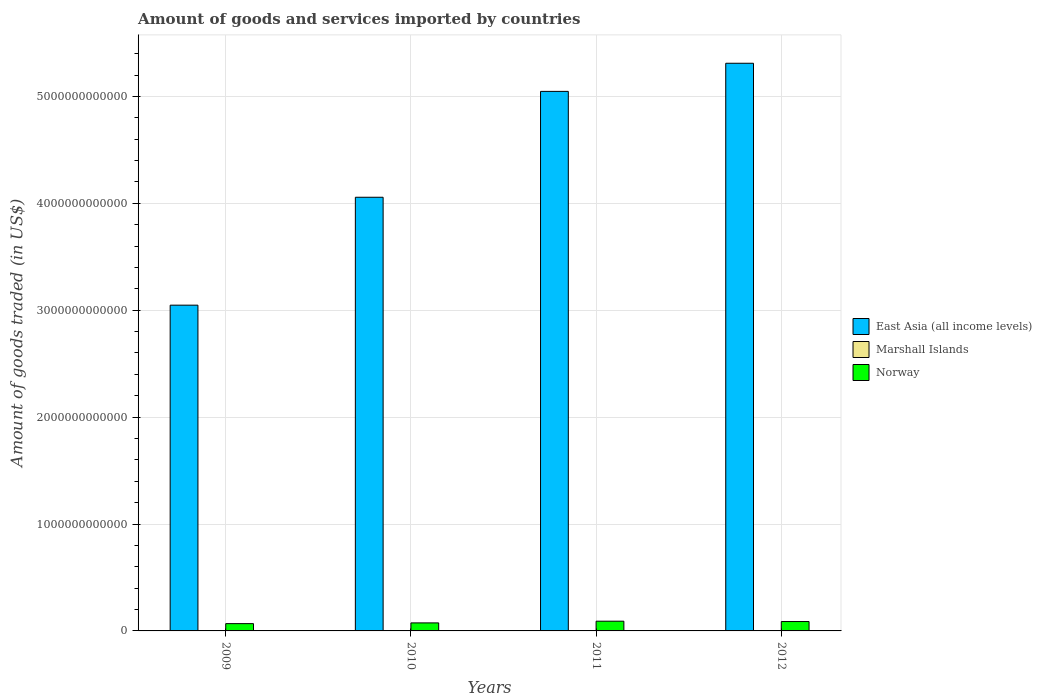Are the number of bars on each tick of the X-axis equal?
Keep it short and to the point. Yes. How many bars are there on the 2nd tick from the left?
Make the answer very short. 3. How many bars are there on the 2nd tick from the right?
Ensure brevity in your answer.  3. What is the label of the 1st group of bars from the left?
Provide a short and direct response. 2009. What is the total amount of goods and services imported in East Asia (all income levels) in 2009?
Ensure brevity in your answer.  3.05e+12. Across all years, what is the maximum total amount of goods and services imported in Marshall Islands?
Provide a short and direct response. 1.22e+08. Across all years, what is the minimum total amount of goods and services imported in Norway?
Make the answer very short. 6.81e+1. In which year was the total amount of goods and services imported in Marshall Islands maximum?
Offer a terse response. 2012. What is the total total amount of goods and services imported in East Asia (all income levels) in the graph?
Provide a short and direct response. 1.75e+13. What is the difference between the total amount of goods and services imported in East Asia (all income levels) in 2011 and that in 2012?
Offer a very short reply. -2.63e+11. What is the difference between the total amount of goods and services imported in Marshall Islands in 2009 and the total amount of goods and services imported in East Asia (all income levels) in 2012?
Provide a succinct answer. -5.31e+12. What is the average total amount of goods and services imported in Norway per year?
Offer a terse response. 8.05e+1. In the year 2010, what is the difference between the total amount of goods and services imported in Marshall Islands and total amount of goods and services imported in East Asia (all income levels)?
Your answer should be very brief. -4.06e+12. In how many years, is the total amount of goods and services imported in Marshall Islands greater than 3800000000000 US$?
Your answer should be very brief. 0. What is the ratio of the total amount of goods and services imported in East Asia (all income levels) in 2009 to that in 2011?
Offer a very short reply. 0.6. What is the difference between the highest and the second highest total amount of goods and services imported in Norway?
Keep it short and to the point. 3.21e+09. What is the difference between the highest and the lowest total amount of goods and services imported in East Asia (all income levels)?
Your response must be concise. 2.26e+12. What does the 2nd bar from the left in 2010 represents?
Provide a succinct answer. Marshall Islands. Is it the case that in every year, the sum of the total amount of goods and services imported in Norway and total amount of goods and services imported in Marshall Islands is greater than the total amount of goods and services imported in East Asia (all income levels)?
Provide a short and direct response. No. How many bars are there?
Keep it short and to the point. 12. How many years are there in the graph?
Ensure brevity in your answer.  4. What is the difference between two consecutive major ticks on the Y-axis?
Make the answer very short. 1.00e+12. Are the values on the major ticks of Y-axis written in scientific E-notation?
Provide a succinct answer. No. Does the graph contain any zero values?
Provide a short and direct response. No. What is the title of the graph?
Keep it short and to the point. Amount of goods and services imported by countries. Does "Palau" appear as one of the legend labels in the graph?
Your answer should be compact. No. What is the label or title of the Y-axis?
Make the answer very short. Amount of goods traded (in US$). What is the Amount of goods traded (in US$) in East Asia (all income levels) in 2009?
Ensure brevity in your answer.  3.05e+12. What is the Amount of goods traded (in US$) of Marshall Islands in 2009?
Keep it short and to the point. 9.43e+07. What is the Amount of goods traded (in US$) in Norway in 2009?
Provide a succinct answer. 6.81e+1. What is the Amount of goods traded (in US$) of East Asia (all income levels) in 2010?
Keep it short and to the point. 4.06e+12. What is the Amount of goods traded (in US$) in Marshall Islands in 2010?
Keep it short and to the point. 1.10e+08. What is the Amount of goods traded (in US$) of Norway in 2010?
Make the answer very short. 7.50e+1. What is the Amount of goods traded (in US$) in East Asia (all income levels) in 2011?
Ensure brevity in your answer.  5.05e+12. What is the Amount of goods traded (in US$) in Marshall Islands in 2011?
Your response must be concise. 1.17e+08. What is the Amount of goods traded (in US$) of Norway in 2011?
Your answer should be compact. 9.10e+1. What is the Amount of goods traded (in US$) of East Asia (all income levels) in 2012?
Your answer should be very brief. 5.31e+12. What is the Amount of goods traded (in US$) in Marshall Islands in 2012?
Provide a short and direct response. 1.22e+08. What is the Amount of goods traded (in US$) of Norway in 2012?
Provide a succinct answer. 8.78e+1. Across all years, what is the maximum Amount of goods traded (in US$) of East Asia (all income levels)?
Offer a very short reply. 5.31e+12. Across all years, what is the maximum Amount of goods traded (in US$) of Marshall Islands?
Your answer should be compact. 1.22e+08. Across all years, what is the maximum Amount of goods traded (in US$) of Norway?
Offer a very short reply. 9.10e+1. Across all years, what is the minimum Amount of goods traded (in US$) of East Asia (all income levels)?
Provide a short and direct response. 3.05e+12. Across all years, what is the minimum Amount of goods traded (in US$) in Marshall Islands?
Provide a succinct answer. 9.43e+07. Across all years, what is the minimum Amount of goods traded (in US$) in Norway?
Provide a succinct answer. 6.81e+1. What is the total Amount of goods traded (in US$) in East Asia (all income levels) in the graph?
Offer a terse response. 1.75e+13. What is the total Amount of goods traded (in US$) in Marshall Islands in the graph?
Keep it short and to the point. 4.43e+08. What is the total Amount of goods traded (in US$) of Norway in the graph?
Provide a short and direct response. 3.22e+11. What is the difference between the Amount of goods traded (in US$) in East Asia (all income levels) in 2009 and that in 2010?
Give a very brief answer. -1.01e+12. What is the difference between the Amount of goods traded (in US$) in Marshall Islands in 2009 and that in 2010?
Ensure brevity in your answer.  -1.52e+07. What is the difference between the Amount of goods traded (in US$) of Norway in 2009 and that in 2010?
Your answer should be compact. -6.91e+09. What is the difference between the Amount of goods traded (in US$) in East Asia (all income levels) in 2009 and that in 2011?
Provide a succinct answer. -2.00e+12. What is the difference between the Amount of goods traded (in US$) in Marshall Islands in 2009 and that in 2011?
Keep it short and to the point. -2.32e+07. What is the difference between the Amount of goods traded (in US$) of Norway in 2009 and that in 2011?
Provide a succinct answer. -2.29e+1. What is the difference between the Amount of goods traded (in US$) in East Asia (all income levels) in 2009 and that in 2012?
Offer a terse response. -2.26e+12. What is the difference between the Amount of goods traded (in US$) in Marshall Islands in 2009 and that in 2012?
Your answer should be very brief. -2.73e+07. What is the difference between the Amount of goods traded (in US$) in Norway in 2009 and that in 2012?
Make the answer very short. -1.97e+1. What is the difference between the Amount of goods traded (in US$) in East Asia (all income levels) in 2010 and that in 2011?
Keep it short and to the point. -9.90e+11. What is the difference between the Amount of goods traded (in US$) in Marshall Islands in 2010 and that in 2011?
Your response must be concise. -7.96e+06. What is the difference between the Amount of goods traded (in US$) of Norway in 2010 and that in 2011?
Your response must be concise. -1.60e+1. What is the difference between the Amount of goods traded (in US$) of East Asia (all income levels) in 2010 and that in 2012?
Your answer should be very brief. -1.25e+12. What is the difference between the Amount of goods traded (in US$) in Marshall Islands in 2010 and that in 2012?
Give a very brief answer. -1.21e+07. What is the difference between the Amount of goods traded (in US$) in Norway in 2010 and that in 2012?
Ensure brevity in your answer.  -1.28e+1. What is the difference between the Amount of goods traded (in US$) in East Asia (all income levels) in 2011 and that in 2012?
Your answer should be very brief. -2.63e+11. What is the difference between the Amount of goods traded (in US$) of Marshall Islands in 2011 and that in 2012?
Offer a very short reply. -4.13e+06. What is the difference between the Amount of goods traded (in US$) of Norway in 2011 and that in 2012?
Ensure brevity in your answer.  3.21e+09. What is the difference between the Amount of goods traded (in US$) in East Asia (all income levels) in 2009 and the Amount of goods traded (in US$) in Marshall Islands in 2010?
Keep it short and to the point. 3.05e+12. What is the difference between the Amount of goods traded (in US$) in East Asia (all income levels) in 2009 and the Amount of goods traded (in US$) in Norway in 2010?
Your answer should be compact. 2.97e+12. What is the difference between the Amount of goods traded (in US$) of Marshall Islands in 2009 and the Amount of goods traded (in US$) of Norway in 2010?
Provide a succinct answer. -7.49e+1. What is the difference between the Amount of goods traded (in US$) of East Asia (all income levels) in 2009 and the Amount of goods traded (in US$) of Marshall Islands in 2011?
Provide a succinct answer. 3.05e+12. What is the difference between the Amount of goods traded (in US$) in East Asia (all income levels) in 2009 and the Amount of goods traded (in US$) in Norway in 2011?
Give a very brief answer. 2.96e+12. What is the difference between the Amount of goods traded (in US$) of Marshall Islands in 2009 and the Amount of goods traded (in US$) of Norway in 2011?
Ensure brevity in your answer.  -9.09e+1. What is the difference between the Amount of goods traded (in US$) in East Asia (all income levels) in 2009 and the Amount of goods traded (in US$) in Marshall Islands in 2012?
Provide a succinct answer. 3.05e+12. What is the difference between the Amount of goods traded (in US$) of East Asia (all income levels) in 2009 and the Amount of goods traded (in US$) of Norway in 2012?
Offer a terse response. 2.96e+12. What is the difference between the Amount of goods traded (in US$) in Marshall Islands in 2009 and the Amount of goods traded (in US$) in Norway in 2012?
Provide a short and direct response. -8.77e+1. What is the difference between the Amount of goods traded (in US$) in East Asia (all income levels) in 2010 and the Amount of goods traded (in US$) in Marshall Islands in 2011?
Provide a succinct answer. 4.06e+12. What is the difference between the Amount of goods traded (in US$) of East Asia (all income levels) in 2010 and the Amount of goods traded (in US$) of Norway in 2011?
Provide a succinct answer. 3.97e+12. What is the difference between the Amount of goods traded (in US$) of Marshall Islands in 2010 and the Amount of goods traded (in US$) of Norway in 2011?
Your answer should be very brief. -9.09e+1. What is the difference between the Amount of goods traded (in US$) in East Asia (all income levels) in 2010 and the Amount of goods traded (in US$) in Marshall Islands in 2012?
Provide a succinct answer. 4.06e+12. What is the difference between the Amount of goods traded (in US$) in East Asia (all income levels) in 2010 and the Amount of goods traded (in US$) in Norway in 2012?
Your response must be concise. 3.97e+12. What is the difference between the Amount of goods traded (in US$) in Marshall Islands in 2010 and the Amount of goods traded (in US$) in Norway in 2012?
Provide a short and direct response. -8.77e+1. What is the difference between the Amount of goods traded (in US$) in East Asia (all income levels) in 2011 and the Amount of goods traded (in US$) in Marshall Islands in 2012?
Your response must be concise. 5.05e+12. What is the difference between the Amount of goods traded (in US$) in East Asia (all income levels) in 2011 and the Amount of goods traded (in US$) in Norway in 2012?
Provide a short and direct response. 4.96e+12. What is the difference between the Amount of goods traded (in US$) of Marshall Islands in 2011 and the Amount of goods traded (in US$) of Norway in 2012?
Offer a terse response. -8.77e+1. What is the average Amount of goods traded (in US$) in East Asia (all income levels) per year?
Your answer should be compact. 4.37e+12. What is the average Amount of goods traded (in US$) of Marshall Islands per year?
Make the answer very short. 1.11e+08. What is the average Amount of goods traded (in US$) in Norway per year?
Your answer should be compact. 8.05e+1. In the year 2009, what is the difference between the Amount of goods traded (in US$) in East Asia (all income levels) and Amount of goods traded (in US$) in Marshall Islands?
Ensure brevity in your answer.  3.05e+12. In the year 2009, what is the difference between the Amount of goods traded (in US$) of East Asia (all income levels) and Amount of goods traded (in US$) of Norway?
Provide a succinct answer. 2.98e+12. In the year 2009, what is the difference between the Amount of goods traded (in US$) of Marshall Islands and Amount of goods traded (in US$) of Norway?
Your answer should be compact. -6.80e+1. In the year 2010, what is the difference between the Amount of goods traded (in US$) in East Asia (all income levels) and Amount of goods traded (in US$) in Marshall Islands?
Provide a short and direct response. 4.06e+12. In the year 2010, what is the difference between the Amount of goods traded (in US$) in East Asia (all income levels) and Amount of goods traded (in US$) in Norway?
Your answer should be very brief. 3.98e+12. In the year 2010, what is the difference between the Amount of goods traded (in US$) of Marshall Islands and Amount of goods traded (in US$) of Norway?
Ensure brevity in your answer.  -7.49e+1. In the year 2011, what is the difference between the Amount of goods traded (in US$) in East Asia (all income levels) and Amount of goods traded (in US$) in Marshall Islands?
Give a very brief answer. 5.05e+12. In the year 2011, what is the difference between the Amount of goods traded (in US$) in East Asia (all income levels) and Amount of goods traded (in US$) in Norway?
Offer a very short reply. 4.96e+12. In the year 2011, what is the difference between the Amount of goods traded (in US$) in Marshall Islands and Amount of goods traded (in US$) in Norway?
Keep it short and to the point. -9.09e+1. In the year 2012, what is the difference between the Amount of goods traded (in US$) of East Asia (all income levels) and Amount of goods traded (in US$) of Marshall Islands?
Your answer should be compact. 5.31e+12. In the year 2012, what is the difference between the Amount of goods traded (in US$) in East Asia (all income levels) and Amount of goods traded (in US$) in Norway?
Give a very brief answer. 5.22e+12. In the year 2012, what is the difference between the Amount of goods traded (in US$) in Marshall Islands and Amount of goods traded (in US$) in Norway?
Your answer should be very brief. -8.77e+1. What is the ratio of the Amount of goods traded (in US$) of East Asia (all income levels) in 2009 to that in 2010?
Ensure brevity in your answer.  0.75. What is the ratio of the Amount of goods traded (in US$) in Marshall Islands in 2009 to that in 2010?
Your answer should be compact. 0.86. What is the ratio of the Amount of goods traded (in US$) of Norway in 2009 to that in 2010?
Your answer should be compact. 0.91. What is the ratio of the Amount of goods traded (in US$) of East Asia (all income levels) in 2009 to that in 2011?
Your answer should be very brief. 0.6. What is the ratio of the Amount of goods traded (in US$) of Marshall Islands in 2009 to that in 2011?
Ensure brevity in your answer.  0.8. What is the ratio of the Amount of goods traded (in US$) of Norway in 2009 to that in 2011?
Keep it short and to the point. 0.75. What is the ratio of the Amount of goods traded (in US$) of East Asia (all income levels) in 2009 to that in 2012?
Ensure brevity in your answer.  0.57. What is the ratio of the Amount of goods traded (in US$) in Marshall Islands in 2009 to that in 2012?
Provide a succinct answer. 0.78. What is the ratio of the Amount of goods traded (in US$) in Norway in 2009 to that in 2012?
Offer a very short reply. 0.78. What is the ratio of the Amount of goods traded (in US$) of East Asia (all income levels) in 2010 to that in 2011?
Your response must be concise. 0.8. What is the ratio of the Amount of goods traded (in US$) of Marshall Islands in 2010 to that in 2011?
Provide a succinct answer. 0.93. What is the ratio of the Amount of goods traded (in US$) of Norway in 2010 to that in 2011?
Make the answer very short. 0.82. What is the ratio of the Amount of goods traded (in US$) of East Asia (all income levels) in 2010 to that in 2012?
Make the answer very short. 0.76. What is the ratio of the Amount of goods traded (in US$) in Marshall Islands in 2010 to that in 2012?
Provide a short and direct response. 0.9. What is the ratio of the Amount of goods traded (in US$) of Norway in 2010 to that in 2012?
Give a very brief answer. 0.85. What is the ratio of the Amount of goods traded (in US$) in East Asia (all income levels) in 2011 to that in 2012?
Provide a short and direct response. 0.95. What is the ratio of the Amount of goods traded (in US$) of Marshall Islands in 2011 to that in 2012?
Make the answer very short. 0.97. What is the ratio of the Amount of goods traded (in US$) in Norway in 2011 to that in 2012?
Offer a very short reply. 1.04. What is the difference between the highest and the second highest Amount of goods traded (in US$) of East Asia (all income levels)?
Keep it short and to the point. 2.63e+11. What is the difference between the highest and the second highest Amount of goods traded (in US$) of Marshall Islands?
Give a very brief answer. 4.13e+06. What is the difference between the highest and the second highest Amount of goods traded (in US$) in Norway?
Provide a succinct answer. 3.21e+09. What is the difference between the highest and the lowest Amount of goods traded (in US$) of East Asia (all income levels)?
Provide a short and direct response. 2.26e+12. What is the difference between the highest and the lowest Amount of goods traded (in US$) in Marshall Islands?
Your answer should be compact. 2.73e+07. What is the difference between the highest and the lowest Amount of goods traded (in US$) of Norway?
Your answer should be compact. 2.29e+1. 